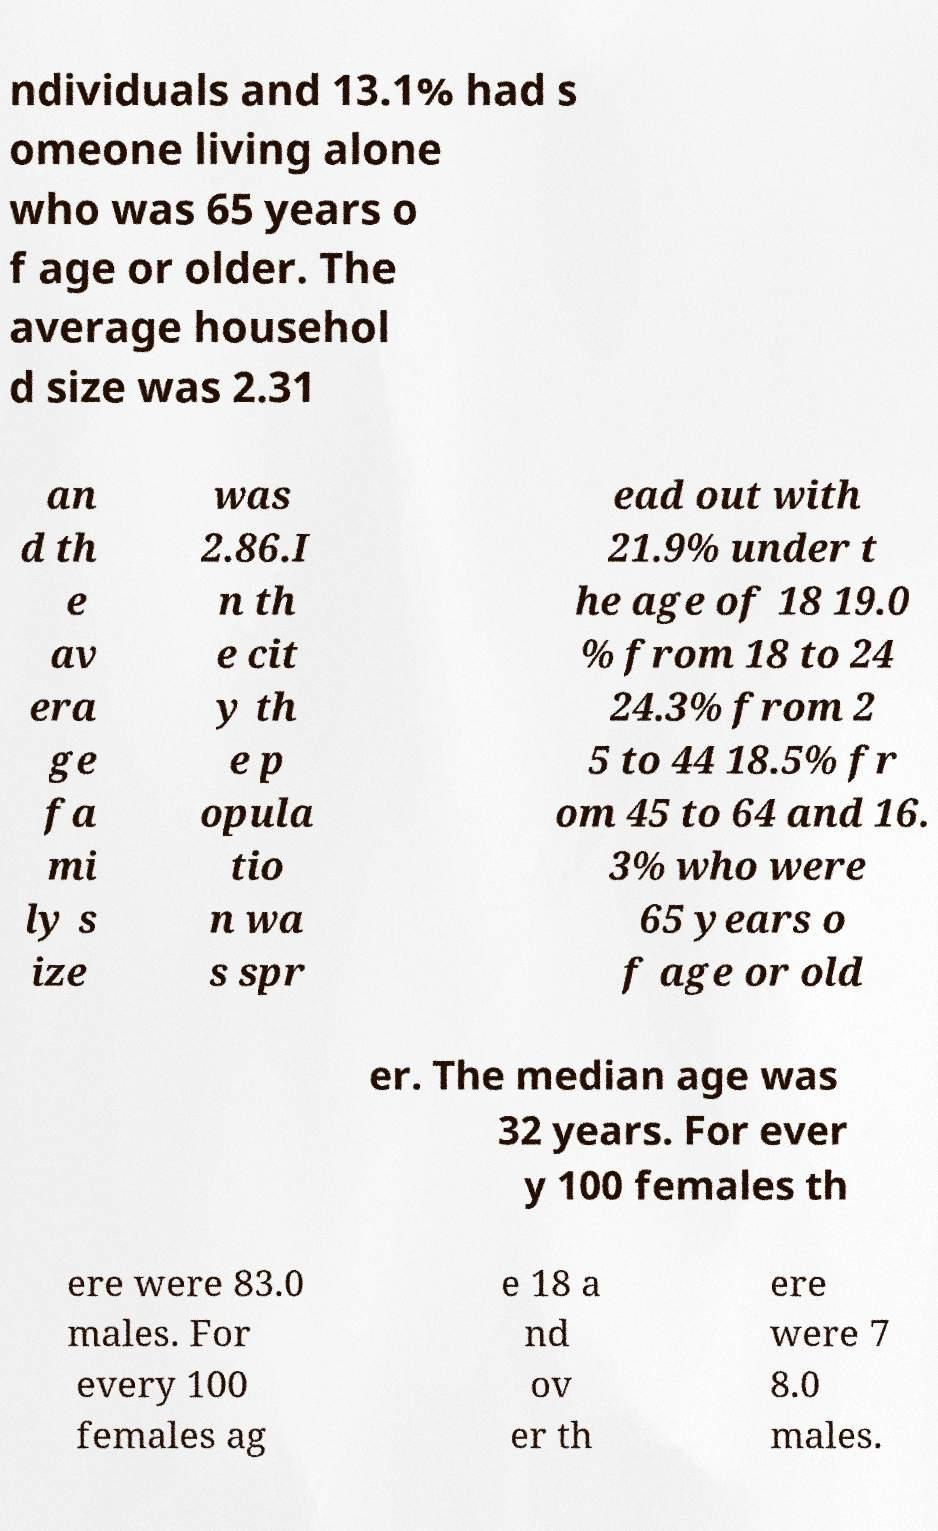Please identify and transcribe the text found in this image. ndividuals and 13.1% had s omeone living alone who was 65 years o f age or older. The average househol d size was 2.31 an d th e av era ge fa mi ly s ize was 2.86.I n th e cit y th e p opula tio n wa s spr ead out with 21.9% under t he age of 18 19.0 % from 18 to 24 24.3% from 2 5 to 44 18.5% fr om 45 to 64 and 16. 3% who were 65 years o f age or old er. The median age was 32 years. For ever y 100 females th ere were 83.0 males. For every 100 females ag e 18 a nd ov er th ere were 7 8.0 males. 